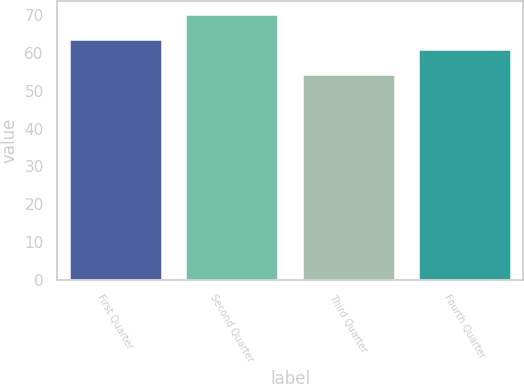Convert chart. <chart><loc_0><loc_0><loc_500><loc_500><bar_chart><fcel>First Quarter<fcel>Second Quarter<fcel>Third Quarter<fcel>Fourth Quarter<nl><fcel>63.81<fcel>70.26<fcel>54.5<fcel>61<nl></chart> 